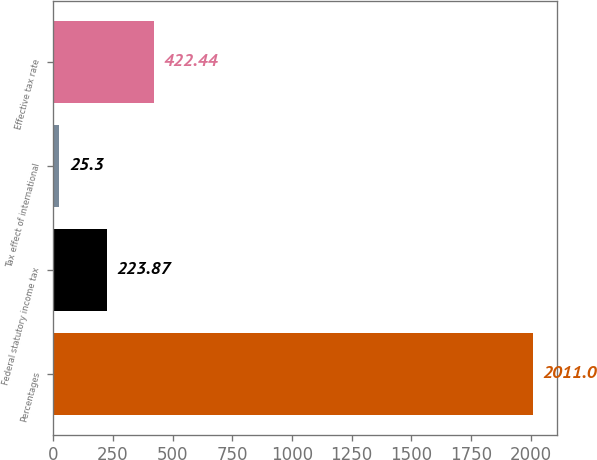<chart> <loc_0><loc_0><loc_500><loc_500><bar_chart><fcel>Percentages<fcel>Federal statutory income tax<fcel>Tax effect of international<fcel>Effective tax rate<nl><fcel>2011<fcel>223.87<fcel>25.3<fcel>422.44<nl></chart> 